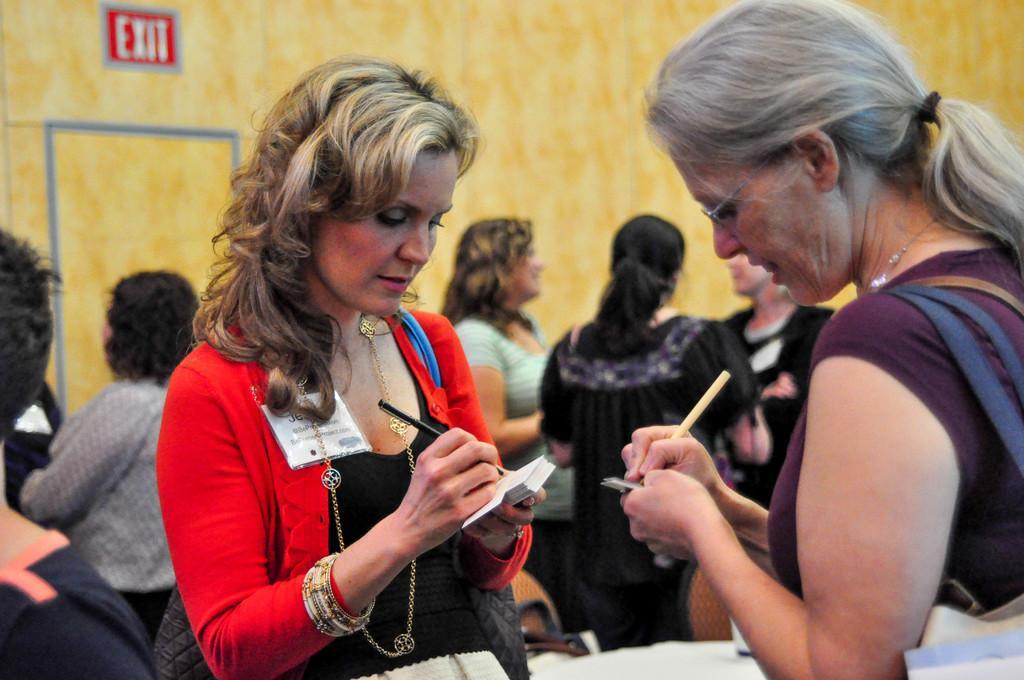Can you describe this image briefly? In this picture there are two women holding a pen in their hand and writing something and there are few other people in the background. 